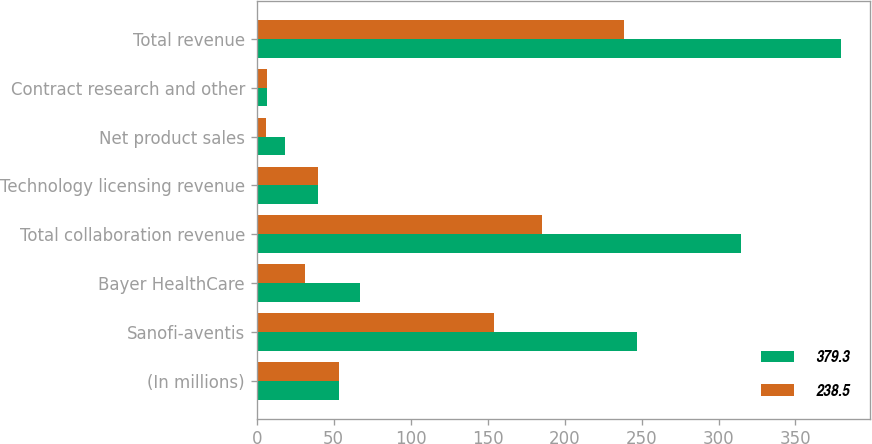<chart> <loc_0><loc_0><loc_500><loc_500><stacked_bar_chart><ecel><fcel>(In millions)<fcel>Sanofi-aventis<fcel>Bayer HealthCare<fcel>Total collaboration revenue<fcel>Technology licensing revenue<fcel>Net product sales<fcel>Contract research and other<fcel>Total revenue<nl><fcel>379.3<fcel>53.65<fcel>247.2<fcel>67.3<fcel>314.5<fcel>40<fcel>18.4<fcel>6.4<fcel>379.3<nl><fcel>238.5<fcel>53.65<fcel>154<fcel>31.2<fcel>185.2<fcel>40<fcel>6.3<fcel>7<fcel>238.5<nl></chart> 